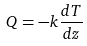Convert formula to latex. <formula><loc_0><loc_0><loc_500><loc_500>Q = - k \frac { d T } { d z }</formula> 